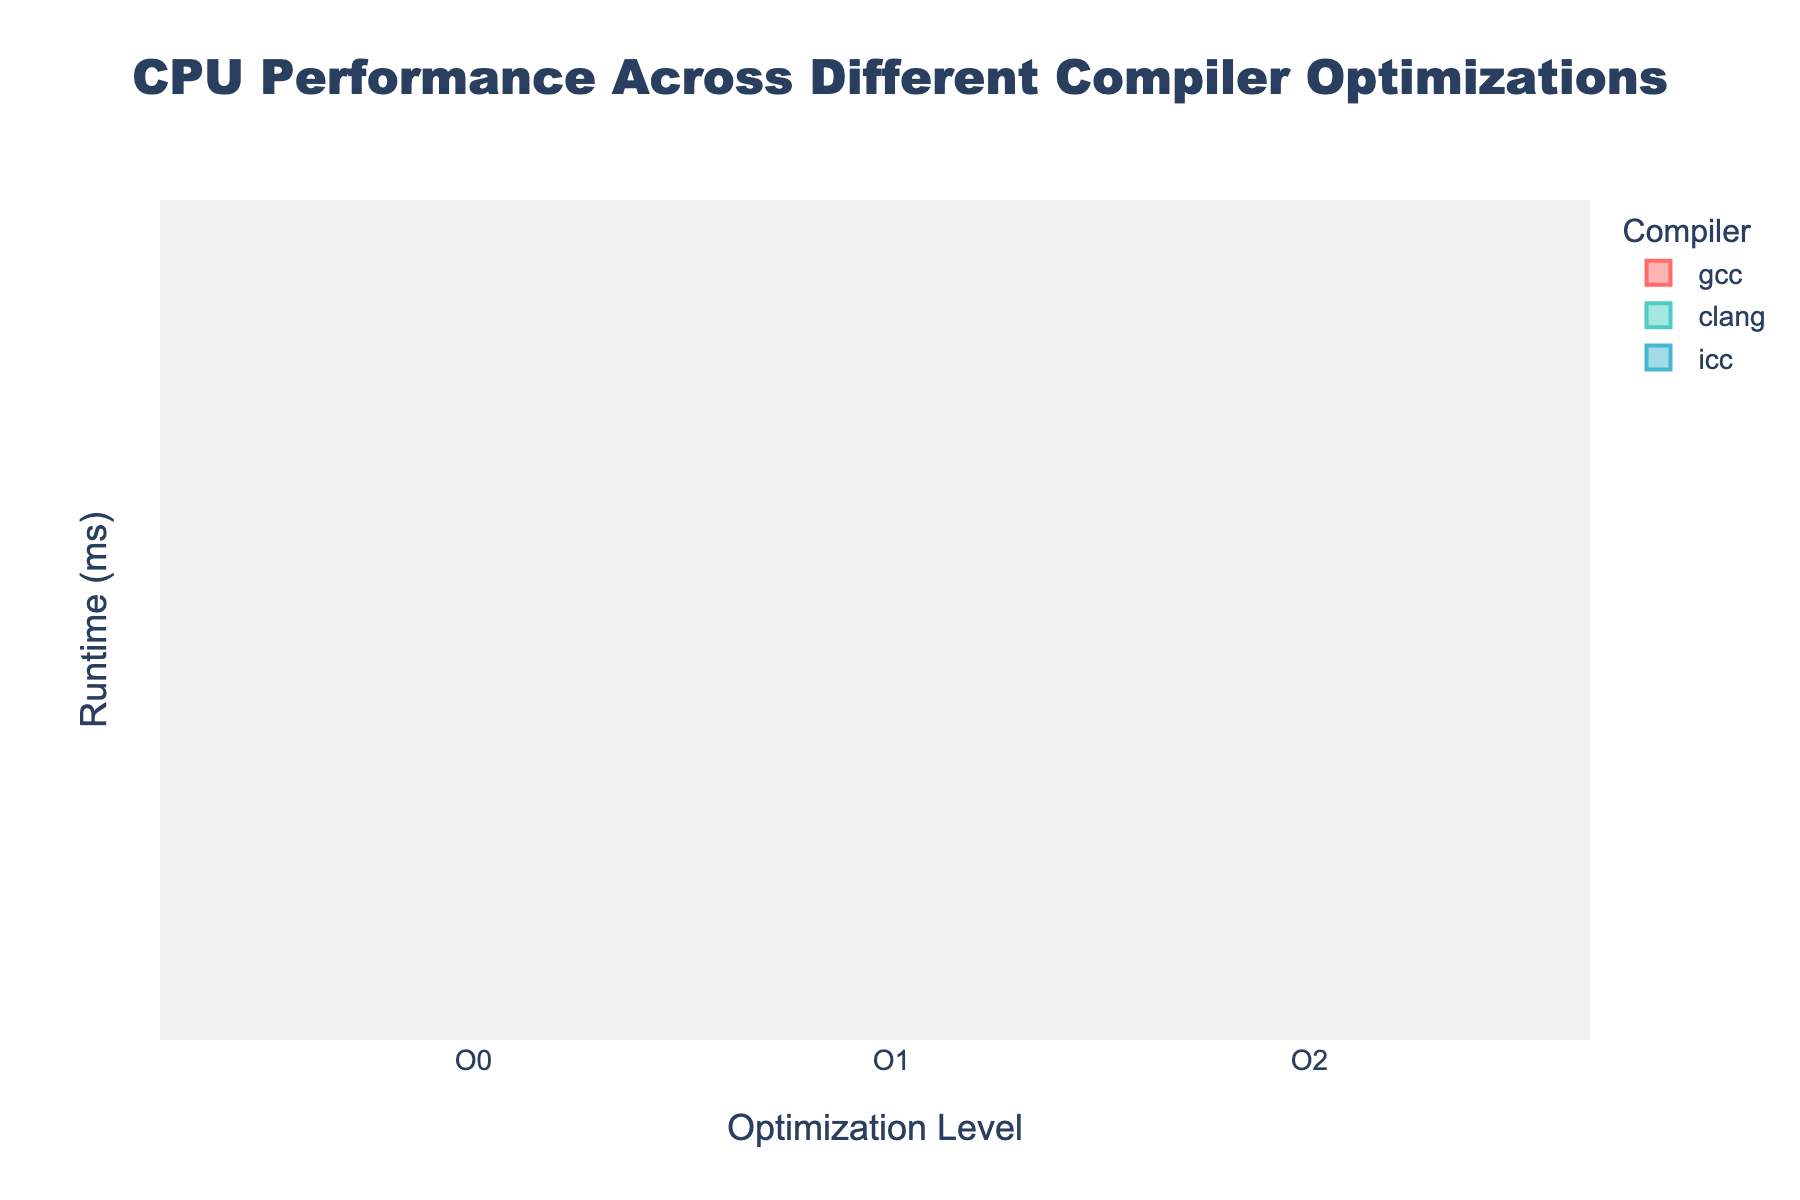How many compiler types are represented in the figure? The title or legend of the figure indicates the different compilers used. There are three distinct compilers: gcc, clang, and icc.
Answer: 3 Which optimization level shows the lowest median runtime for the gcc compiler? Observe the box plots for gcc and identify the median lines. The optimization level O3 has the lowest median line compared to other levels.
Answer: O3 Compare the median runtimes of optimization level O0 for gcc and clang compilers. Which is higher? Look at the median lines for O0 of both gcc and clang. Clang exhibits a higher median runtime compared to gcc.
Answer: clang Which compiler has the most consistent runtime performance (smallest interquartile range) at optimization level O2? Examine the width of the boxes at O2 for each compiler. The icc compiler has the smallest interquartile range, indicating the most consistent runtime performance.
Answer: icc What can you infer about the effect of higher optimization levels (O2, O3) on runtime performance across all compilers? Higher optimization levels (O2, O3) generally result in lower runtime performance as indicated by the lower position of the boxes and median lines for these levels.
Answer: Lower runtimes Is there any instance where an optimization level shows a non-overlapping notch with an immediately higher optimization level for any compiler? Check the notches of consecutive optimization levels for each compiler. For gcc, O0 and O1 do not have overlapping notches, indicating a significant difference in their medians.
Answer: gcc O0 and O1 Which optimization level has the highest median runtime for the icc compiler? Look at the median lines across optimization levels for icc. The highest median line appears at O0.
Answer: O0 Between gcc and icc at optimization level O3, which compiler shows a lower median runtime? Compare the positions of the median lines at O3 for gcc and icc. The median line for icc O3 is lower than that for gcc O3.
Answer: icc Which compiler demonstrates the greatest reduction in median runtime from O0 to O3? Look at the median lines for O0 and O3 for each compiler. The clang compiler shows the most significant reduction in median runtime from O0 to O3.
Answer: clang 